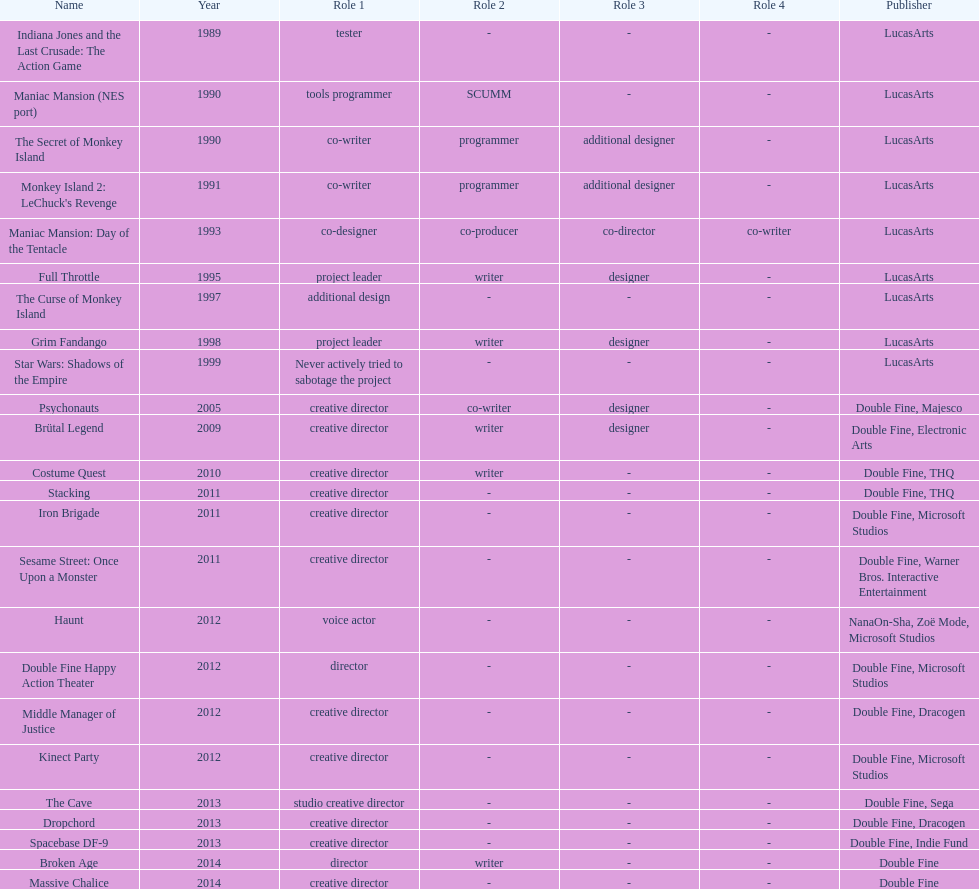Which game is credited with a creative director and warner bros. interactive entertainment as their creative director? Sesame Street: Once Upon a Monster. 